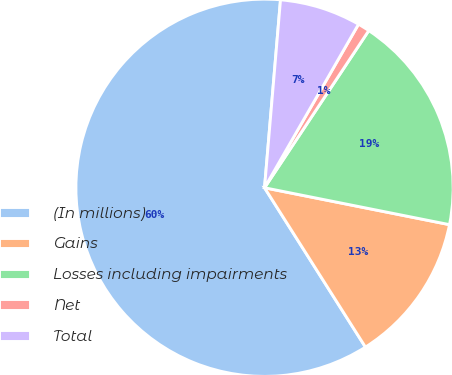Convert chart. <chart><loc_0><loc_0><loc_500><loc_500><pie_chart><fcel>(In millions)<fcel>Gains<fcel>Losses including impairments<fcel>Net<fcel>Total<nl><fcel>60.33%<fcel>12.88%<fcel>18.81%<fcel>1.02%<fcel>6.95%<nl></chart> 